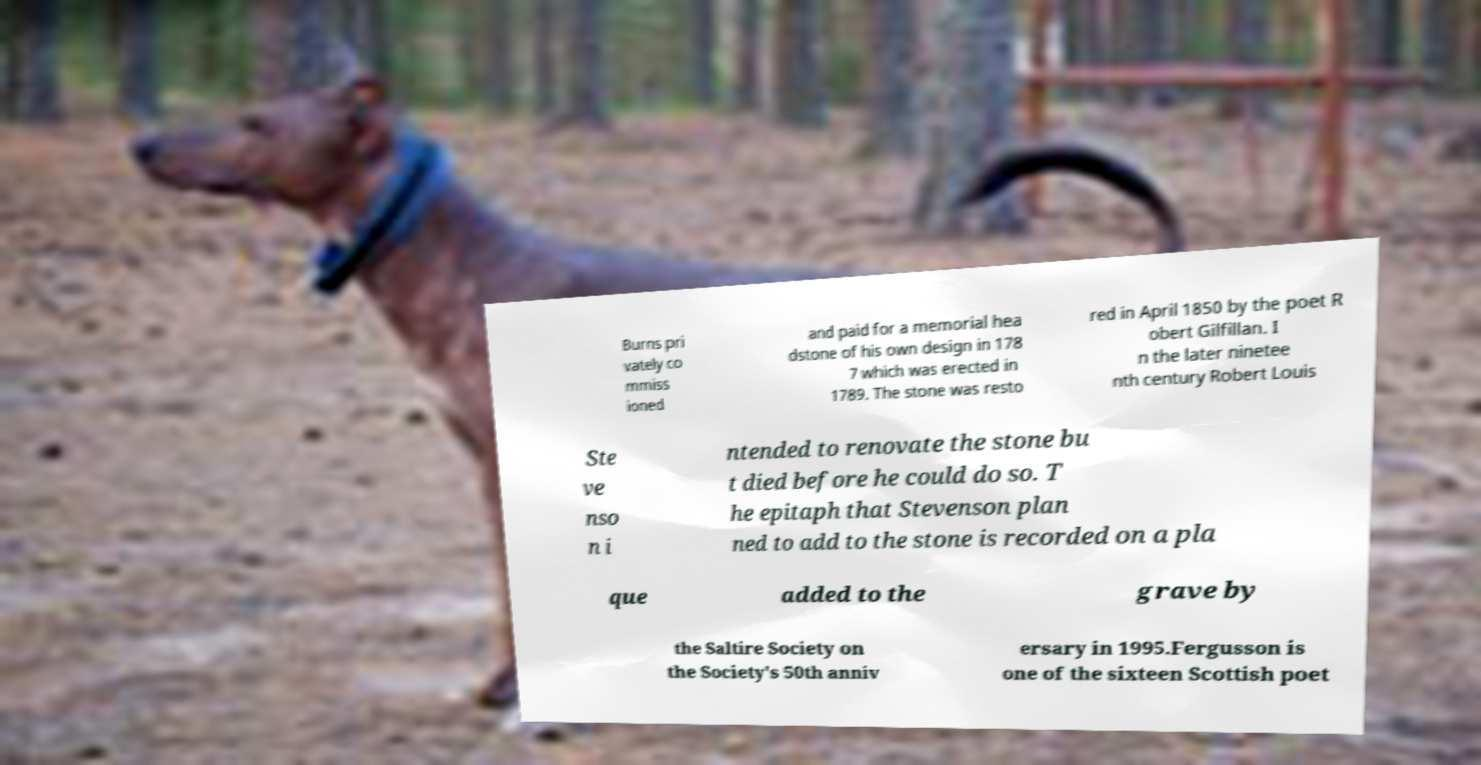Could you assist in decoding the text presented in this image and type it out clearly? Burns pri vately co mmiss ioned and paid for a memorial hea dstone of his own design in 178 7 which was erected in 1789. The stone was resto red in April 1850 by the poet R obert Gilfillan. I n the later ninetee nth century Robert Louis Ste ve nso n i ntended to renovate the stone bu t died before he could do so. T he epitaph that Stevenson plan ned to add to the stone is recorded on a pla que added to the grave by the Saltire Society on the Society's 50th anniv ersary in 1995.Fergusson is one of the sixteen Scottish poet 